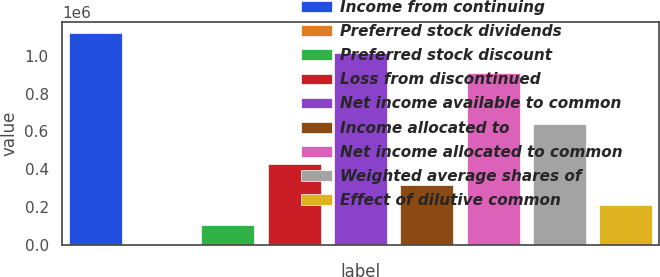Convert chart. <chart><loc_0><loc_0><loc_500><loc_500><bar_chart><fcel>Income from continuing<fcel>Preferred stock dividends<fcel>Preferred stock discount<fcel>Loss from discontinued<fcel>Net income available to common<fcel>Income allocated to<fcel>Net income allocated to common<fcel>Weighted average shares of<fcel>Effect of dilutive common<nl><fcel>1.12309e+06<fcel>2.72<fcel>106294<fcel>425167<fcel>1.0168e+06<fcel>318876<fcel>910510<fcel>637749<fcel>212585<nl></chart> 